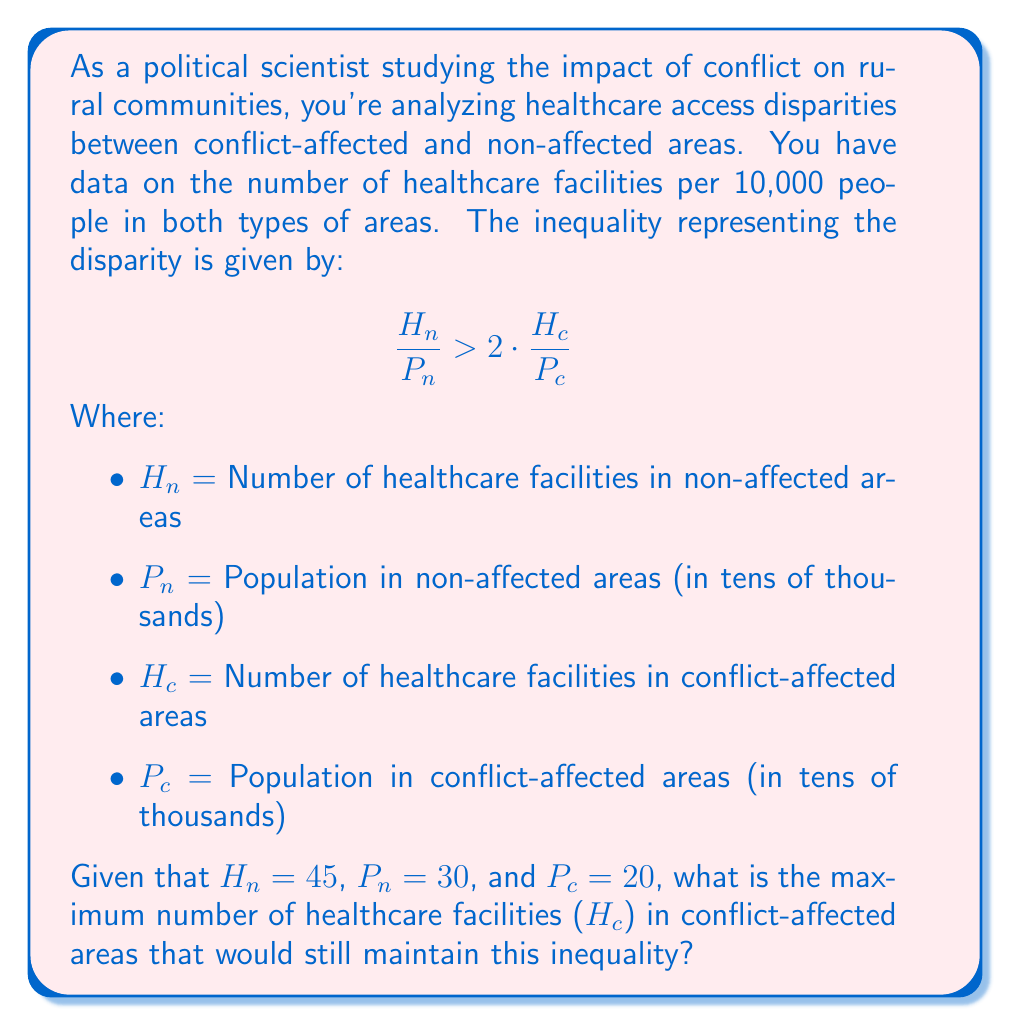Give your solution to this math problem. To solve this problem, we need to follow these steps:

1) First, let's substitute the known values into the inequality:

   $$ \frac{45}{30} > 2 \cdot \frac{H_c}{20} $$

2) Simplify the left side of the inequality:

   $$ 1.5 > 2 \cdot \frac{H_c}{20} $$

3) Multiply both sides by 20:

   $$ 30 > 2H_c $$

4) Divide both sides by 2:

   $$ 15 > H_c $$

5) Since we're looking for the maximum number of healthcare facilities in conflict-affected areas that maintains the inequality, we need the largest integer value of $H_c$ that satisfies this inequality.

6) The largest integer less than 15 is 14.

Therefore, the maximum number of healthcare facilities in conflict-affected areas that would still maintain the given inequality is 14.
Answer: 14 healthcare facilities 